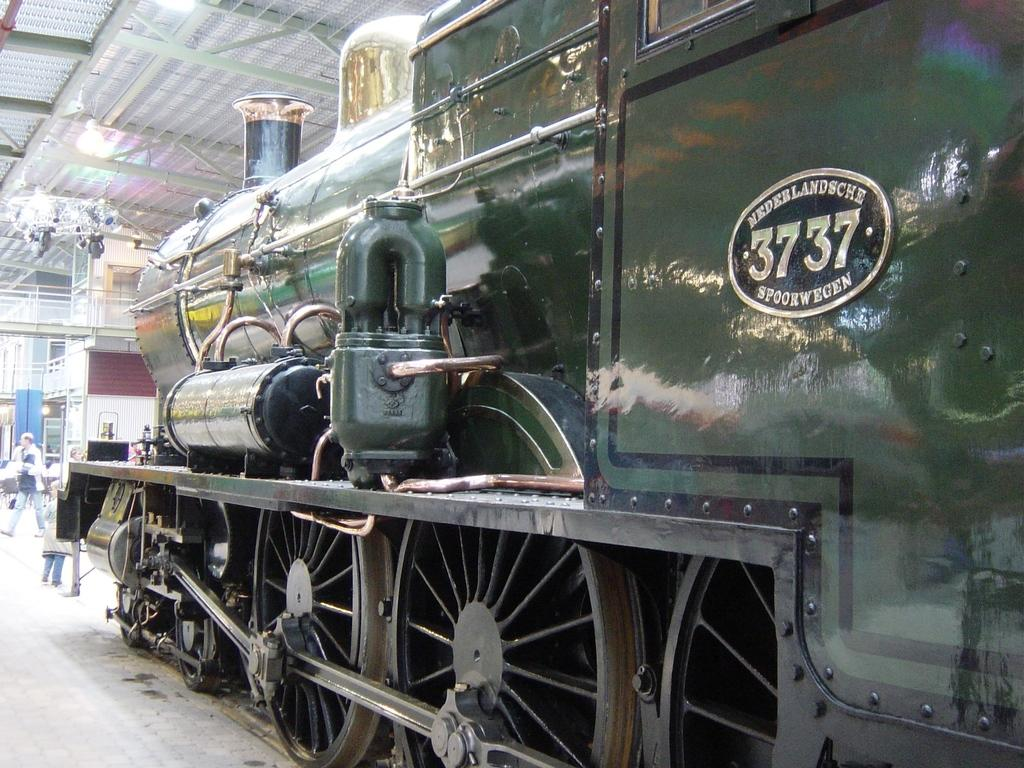What is the main subject of the image? There is a railway engine in the center of the image. What can be seen in the background of the image? There are persons, a bridge, and lights in the background of the image. What type of net can be seen catching a star in the image? There is no net or star present in the image. 